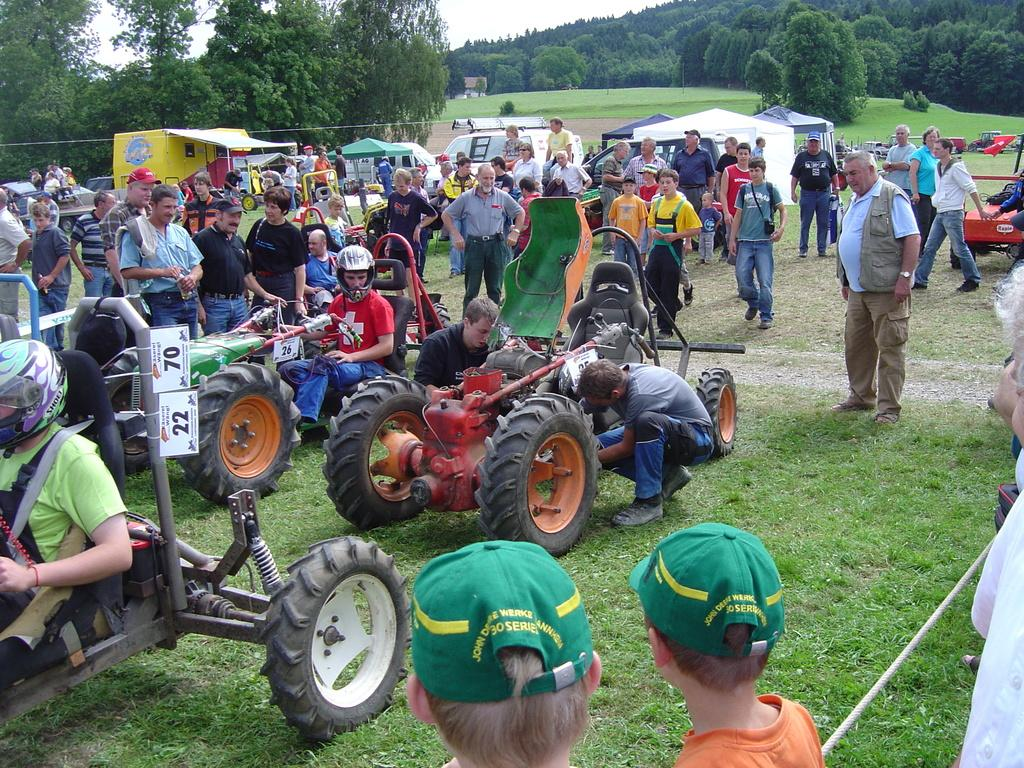What types of objects can be seen in the image? There are vehicles in the image. What can be seen in the background of the image? There is green grass and trees visible in the image. Are there any people present in the image? Yes, there are people standing in the image. What type of lock is used to secure the parcel in the image? There is no parcel or lock present in the image. How does the cover protect the vehicles in the image? There is no cover present in the image; the vehicles are exposed to the environment. 